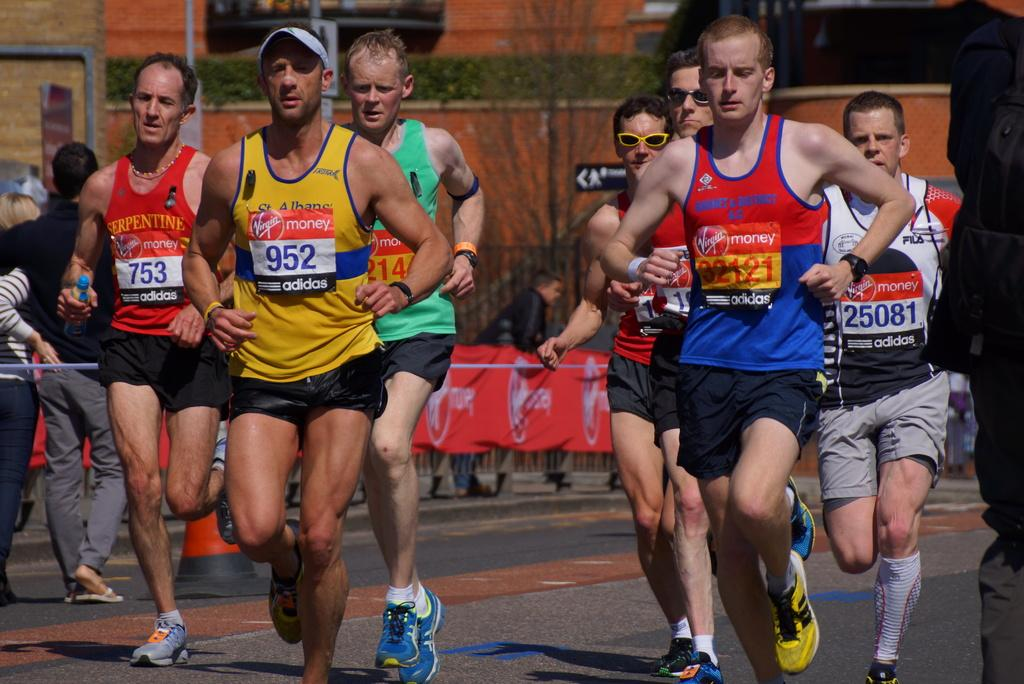Provide a one-sentence caption for the provided image. runners in a running race sponsored by Virgin Money and Adidas on the bibs. 